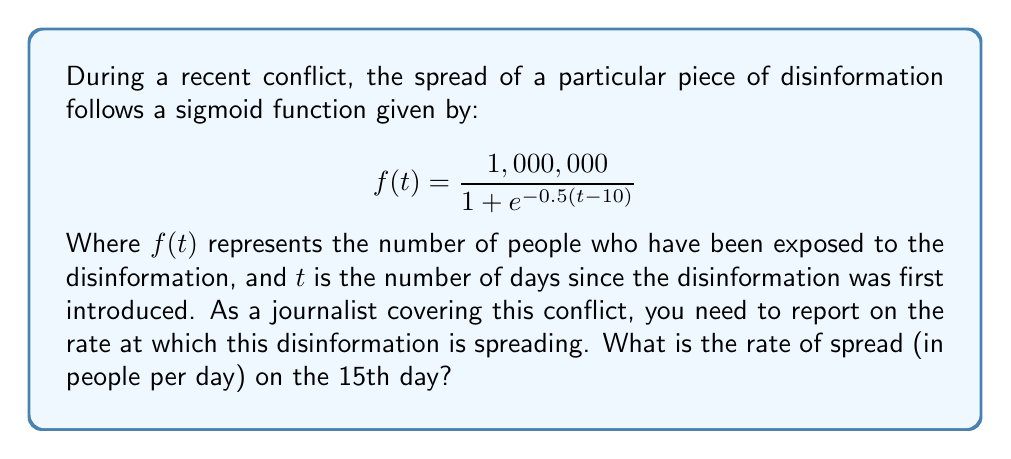Give your solution to this math problem. To find the rate of spread on the 15th day, we need to calculate the derivative of the sigmoid function at t = 15. Here's how we do it step-by-step:

1) The general form of the derivative of a sigmoid function is:
   $$f'(t) = f(t) \cdot (1 - f(t)/K) \cdot r$$
   Where K is the carrying capacity (maximum value) and r is the growth rate.

2) In our case, K = 1,000,000 and r = 0.5

3) First, let's calculate f(15):
   $$f(15) = \frac{1,000,000}{1 + e^{-0.5(15-10)}} = \frac{1,000,000}{1 + e^{-2.5}} \approx 924,141.76$$

4) Now we can plug this into our derivative formula:
   $$f'(15) = 924,141.76 \cdot (1 - 924,141.76/1,000,000) \cdot 0.5$$

5) Simplifying:
   $$f'(15) = 924,141.76 \cdot 0.075858 \cdot 0.5 \approx 35,048.69$$

Therefore, on the 15th day, the disinformation is spreading at a rate of approximately 35,049 people per day.
Answer: 35,049 people/day 